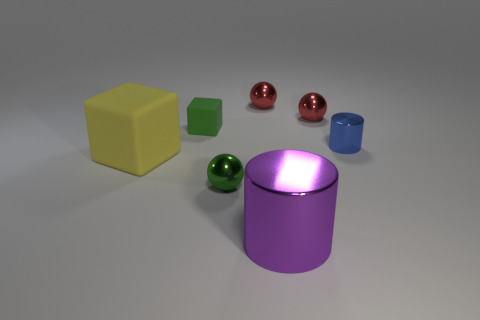Add 1 tiny blue objects. How many objects exist? 8 Subtract all blocks. How many objects are left? 5 Subtract all small blue cylinders. Subtract all metal cylinders. How many objects are left? 4 Add 7 big cubes. How many big cubes are left? 8 Add 6 green rubber cylinders. How many green rubber cylinders exist? 6 Subtract 0 red cylinders. How many objects are left? 7 